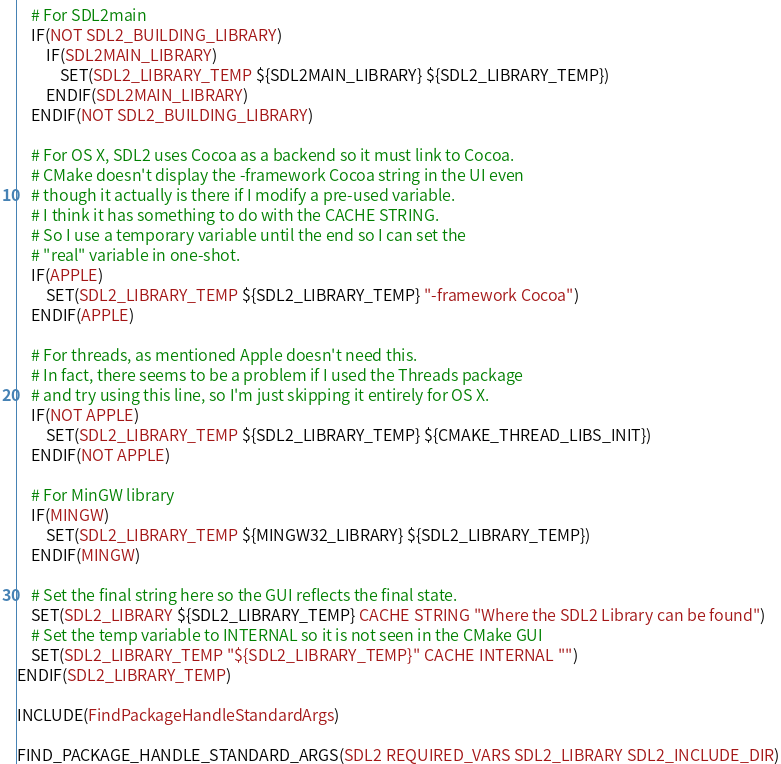Convert code to text. <code><loc_0><loc_0><loc_500><loc_500><_CMake_>    # For SDL2main
    IF(NOT SDL2_BUILDING_LIBRARY)
        IF(SDL2MAIN_LIBRARY)
            SET(SDL2_LIBRARY_TEMP ${SDL2MAIN_LIBRARY} ${SDL2_LIBRARY_TEMP})
        ENDIF(SDL2MAIN_LIBRARY)
    ENDIF(NOT SDL2_BUILDING_LIBRARY)

    # For OS X, SDL2 uses Cocoa as a backend so it must link to Cocoa.
    # CMake doesn't display the -framework Cocoa string in the UI even
    # though it actually is there if I modify a pre-used variable.
    # I think it has something to do with the CACHE STRING.
    # So I use a temporary variable until the end so I can set the
    # "real" variable in one-shot.
    IF(APPLE)
        SET(SDL2_LIBRARY_TEMP ${SDL2_LIBRARY_TEMP} "-framework Cocoa")
    ENDIF(APPLE)

    # For threads, as mentioned Apple doesn't need this.
    # In fact, there seems to be a problem if I used the Threads package
    # and try using this line, so I'm just skipping it entirely for OS X.
    IF(NOT APPLE)
        SET(SDL2_LIBRARY_TEMP ${SDL2_LIBRARY_TEMP} ${CMAKE_THREAD_LIBS_INIT})
    ENDIF(NOT APPLE)

    # For MinGW library
    IF(MINGW)
        SET(SDL2_LIBRARY_TEMP ${MINGW32_LIBRARY} ${SDL2_LIBRARY_TEMP})
    ENDIF(MINGW)

    # Set the final string here so the GUI reflects the final state.
    SET(SDL2_LIBRARY ${SDL2_LIBRARY_TEMP} CACHE STRING "Where the SDL2 Library can be found")
    # Set the temp variable to INTERNAL so it is not seen in the CMake GUI
    SET(SDL2_LIBRARY_TEMP "${SDL2_LIBRARY_TEMP}" CACHE INTERNAL "")
ENDIF(SDL2_LIBRARY_TEMP)

INCLUDE(FindPackageHandleStandardArgs)

FIND_PACKAGE_HANDLE_STANDARD_ARGS(SDL2 REQUIRED_VARS SDL2_LIBRARY SDL2_INCLUDE_DIR)
</code> 